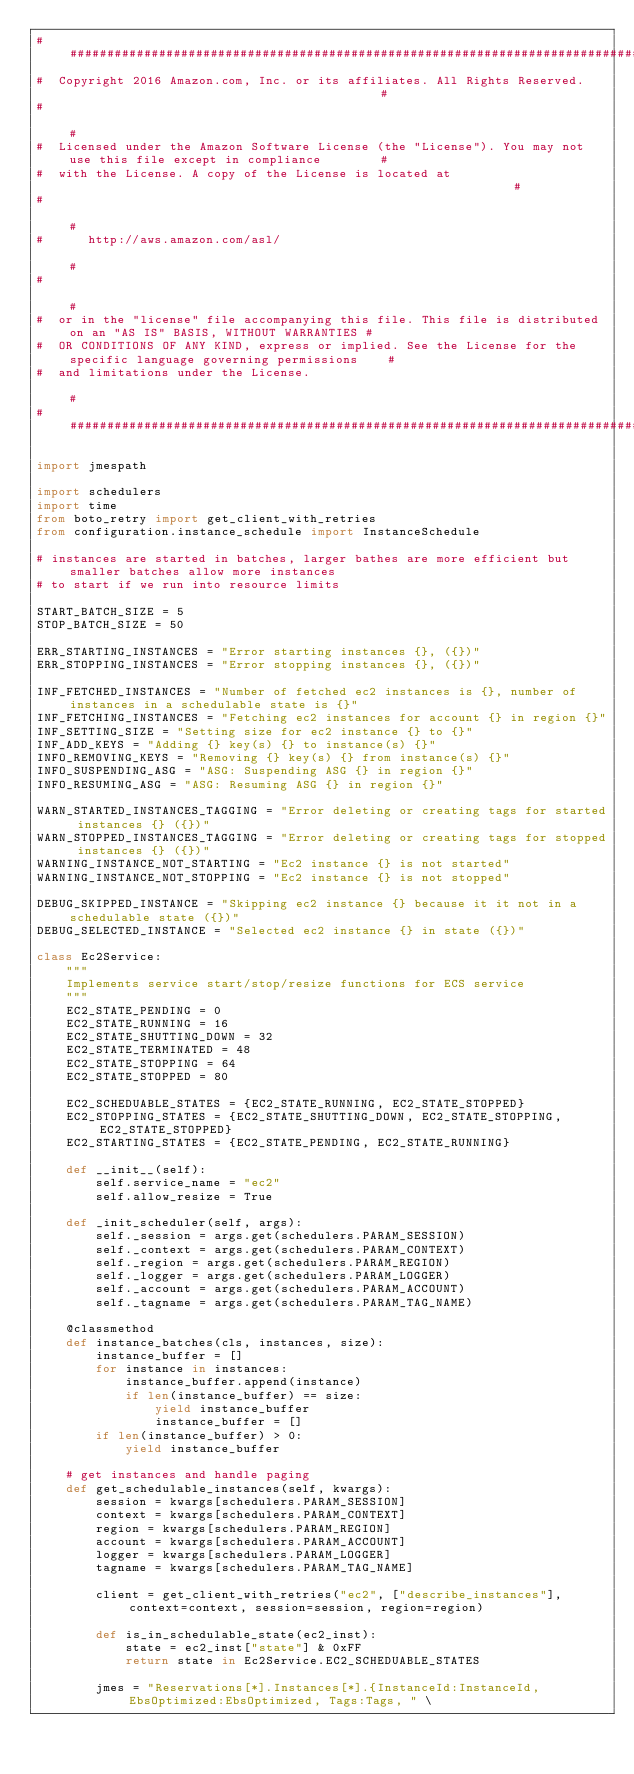<code> <loc_0><loc_0><loc_500><loc_500><_Python_>######################################################################################################################
#  Copyright 2016 Amazon.com, Inc. or its affiliates. All Rights Reserved.                                           #
#                                                                                                                    #
#  Licensed under the Amazon Software License (the "License"). You may not use this file except in compliance        #
#  with the License. A copy of the License is located at                                                             #
#                                                                                                                    #
#      http://aws.amazon.com/asl/                                                                                    #
#                                                                                                                    #
#  or in the "license" file accompanying this file. This file is distributed on an "AS IS" BASIS, WITHOUT WARRANTIES #
#  OR CONDITIONS OF ANY KIND, express or implied. See the License for the specific language governing permissions    #
#  and limitations under the License.                                                                                #
######################################################################################################################

import jmespath

import schedulers
import time
from boto_retry import get_client_with_retries
from configuration.instance_schedule import InstanceSchedule

# instances are started in batches, larger bathes are more efficient but smaller batches allow more instances
# to start if we run into resource limits

START_BATCH_SIZE = 5
STOP_BATCH_SIZE = 50

ERR_STARTING_INSTANCES = "Error starting instances {}, ({})"
ERR_STOPPING_INSTANCES = "Error stopping instances {}, ({})"

INF_FETCHED_INSTANCES = "Number of fetched ec2 instances is {}, number of instances in a schedulable state is {}"
INF_FETCHING_INSTANCES = "Fetching ec2 instances for account {} in region {}"
INF_SETTING_SIZE = "Setting size for ec2 instance {} to {}"
INF_ADD_KEYS = "Adding {} key(s) {} to instance(s) {}"
INFO_REMOVING_KEYS = "Removing {} key(s) {} from instance(s) {}"
INFO_SUSPENDING_ASG = "ASG: Suspending ASG {} in region {}"
INFO_RESUMING_ASG = "ASG: Resuming ASG {} in region {}"

WARN_STARTED_INSTANCES_TAGGING = "Error deleting or creating tags for started instances {} ({})"
WARN_STOPPED_INSTANCES_TAGGING = "Error deleting or creating tags for stopped instances {} ({})"
WARNING_INSTANCE_NOT_STARTING = "Ec2 instance {} is not started"
WARNING_INSTANCE_NOT_STOPPING = "Ec2 instance {} is not stopped"

DEBUG_SKIPPED_INSTANCE = "Skipping ec2 instance {} because it it not in a schedulable state ({})"
DEBUG_SELECTED_INSTANCE = "Selected ec2 instance {} in state ({})"

class Ec2Service:
    """
    Implements service start/stop/resize functions for ECS service
    """
    EC2_STATE_PENDING = 0
    EC2_STATE_RUNNING = 16
    EC2_STATE_SHUTTING_DOWN = 32
    EC2_STATE_TERMINATED = 48
    EC2_STATE_STOPPING = 64
    EC2_STATE_STOPPED = 80

    EC2_SCHEDUABLE_STATES = {EC2_STATE_RUNNING, EC2_STATE_STOPPED}
    EC2_STOPPING_STATES = {EC2_STATE_SHUTTING_DOWN, EC2_STATE_STOPPING, EC2_STATE_STOPPED}
    EC2_STARTING_STATES = {EC2_STATE_PENDING, EC2_STATE_RUNNING}

    def __init__(self):
        self.service_name = "ec2"
        self.allow_resize = True

    def _init_scheduler(self, args):
        self._session = args.get(schedulers.PARAM_SESSION)
        self._context = args.get(schedulers.PARAM_CONTEXT)
        self._region = args.get(schedulers.PARAM_REGION)
        self._logger = args.get(schedulers.PARAM_LOGGER)
        self._account = args.get(schedulers.PARAM_ACCOUNT)
        self._tagname = args.get(schedulers.PARAM_TAG_NAME)

    @classmethod
    def instance_batches(cls, instances, size):
        instance_buffer = []
        for instance in instances:
            instance_buffer.append(instance)
            if len(instance_buffer) == size:
                yield instance_buffer
                instance_buffer = []
        if len(instance_buffer) > 0:
            yield instance_buffer

    # get instances and handle paging
    def get_schedulable_instances(self, kwargs):
        session = kwargs[schedulers.PARAM_SESSION]
        context = kwargs[schedulers.PARAM_CONTEXT]
        region = kwargs[schedulers.PARAM_REGION]
        account = kwargs[schedulers.PARAM_ACCOUNT]
        logger = kwargs[schedulers.PARAM_LOGGER]
        tagname = kwargs[schedulers.PARAM_TAG_NAME]

        client = get_client_with_retries("ec2", ["describe_instances"], context=context, session=session, region=region)

        def is_in_schedulable_state(ec2_inst):
            state = ec2_inst["state"] & 0xFF
            return state in Ec2Service.EC2_SCHEDUABLE_STATES

        jmes = "Reservations[*].Instances[*].{InstanceId:InstanceId, EbsOptimized:EbsOptimized, Tags:Tags, " \</code> 